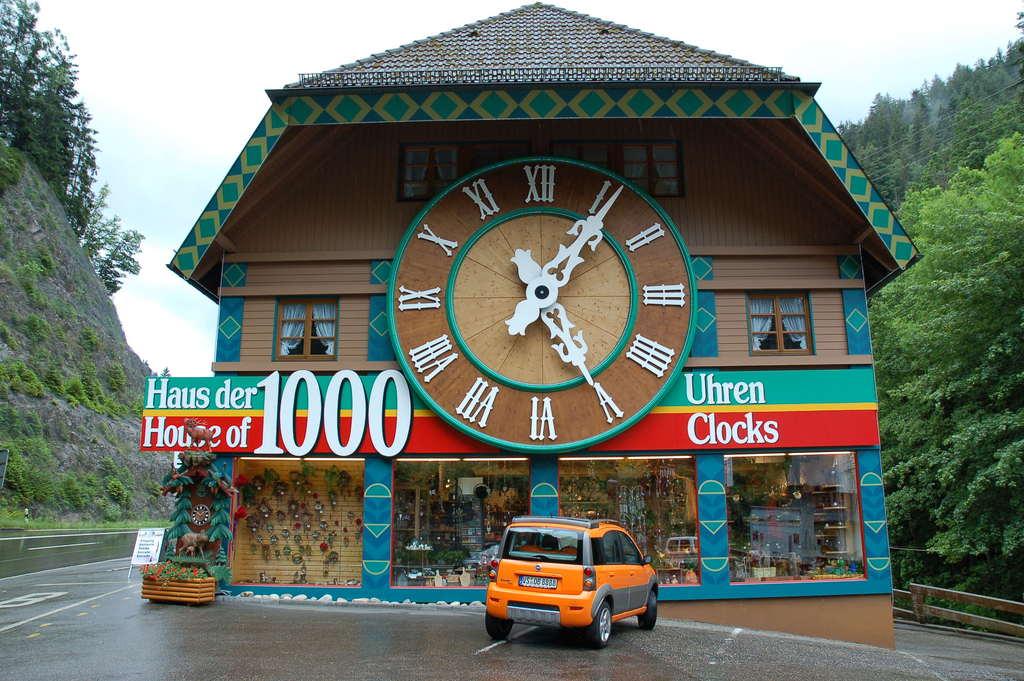What is the name of the store?
Give a very brief answer. House of 1000 clocks. Is this a clock store in sweden?
Your answer should be very brief. Yes. 